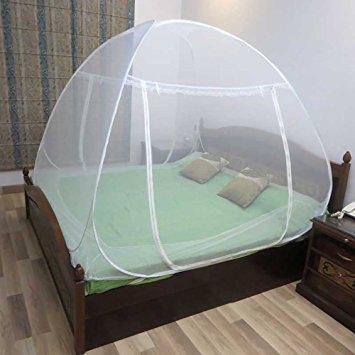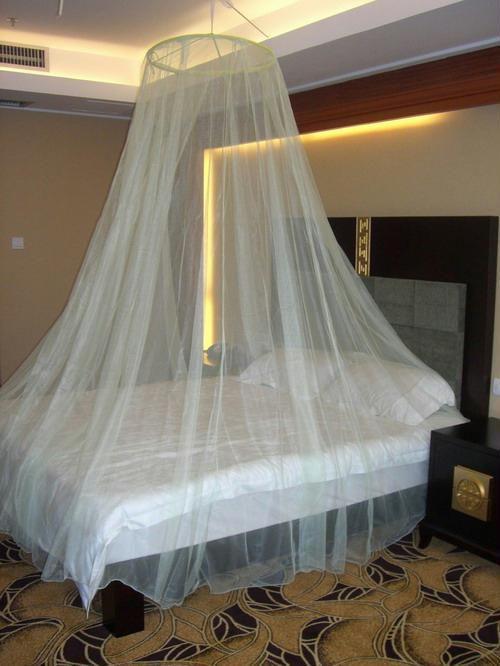The first image is the image on the left, the second image is the image on the right. Considering the images on both sides, is "There is a nightstand next to a rounded mosquito net or canopy that covers the bed." valid? Answer yes or no. Yes. The first image is the image on the left, the second image is the image on the right. For the images shown, is this caption "None of the nets above the bed are pink or yellow." true? Answer yes or no. Yes. The first image is the image on the left, the second image is the image on the right. Evaluate the accuracy of this statement regarding the images: "The left image shows a rounded dome bed enclosure.". Is it true? Answer yes or no. Yes. 